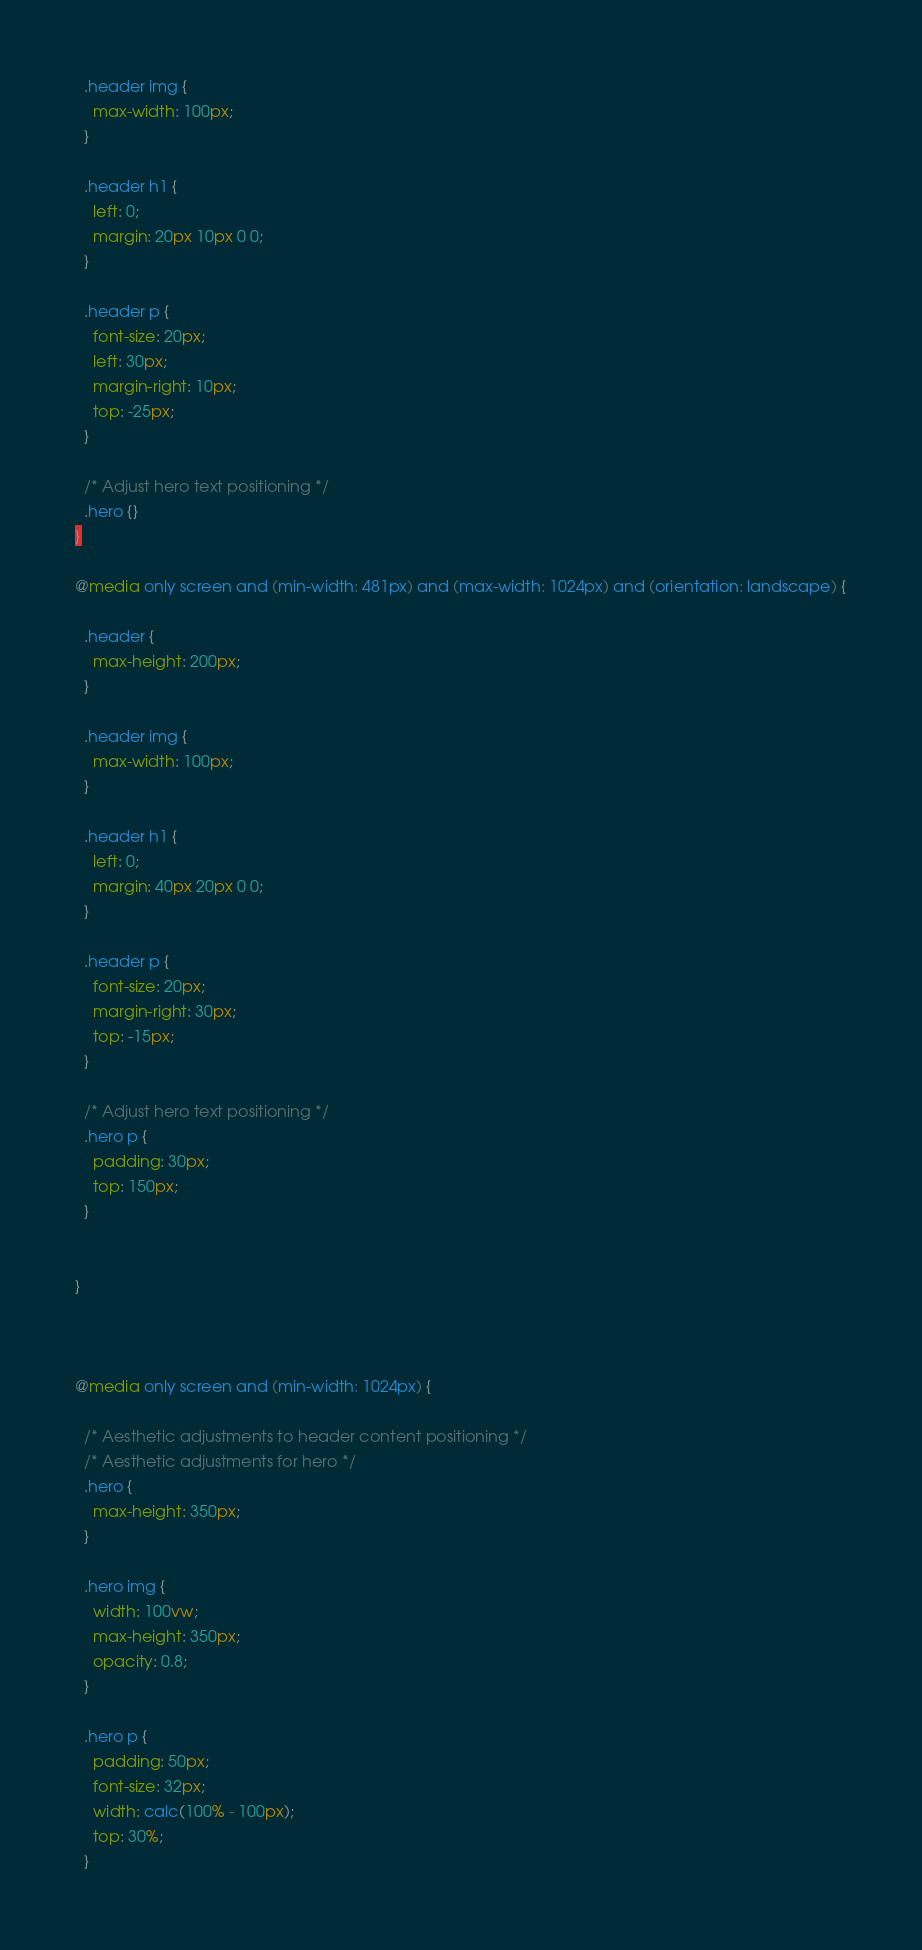Convert code to text. <code><loc_0><loc_0><loc_500><loc_500><_CSS_>
  .header img {
    max-width: 100px;
  }

  .header h1 {
    left: 0;
    margin: 20px 10px 0 0;
  }

  .header p {
    font-size: 20px;
    left: 30px;
    margin-right: 10px;
    top: -25px;
  }

  /* Adjust hero text positioning */
  .hero {}
}

@media only screen and (min-width: 481px) and (max-width: 1024px) and (orientation: landscape) {

  .header {
    max-height: 200px;
  }

  .header img {
    max-width: 100px;
  }

  .header h1 {
    left: 0;
    margin: 40px 20px 0 0;
  }

  .header p {
    font-size: 20px;
    margin-right: 30px;
    top: -15px;
  }

  /* Adjust hero text positioning */
  .hero p {
    padding: 30px;
    top: 150px;
  }


}



@media only screen and (min-width: 1024px) {

  /* Aesthetic adjustments to header content positioning */
  /* Aesthetic adjustments for hero */
  .hero {
    max-height: 350px;
  }

  .hero img {
    width: 100vw;
    max-height: 350px;
    opacity: 0.8;
  }

  .hero p {
    padding: 50px;
    font-size: 32px;
    width: calc(100% - 100px);
    top: 30%;
  }</code> 